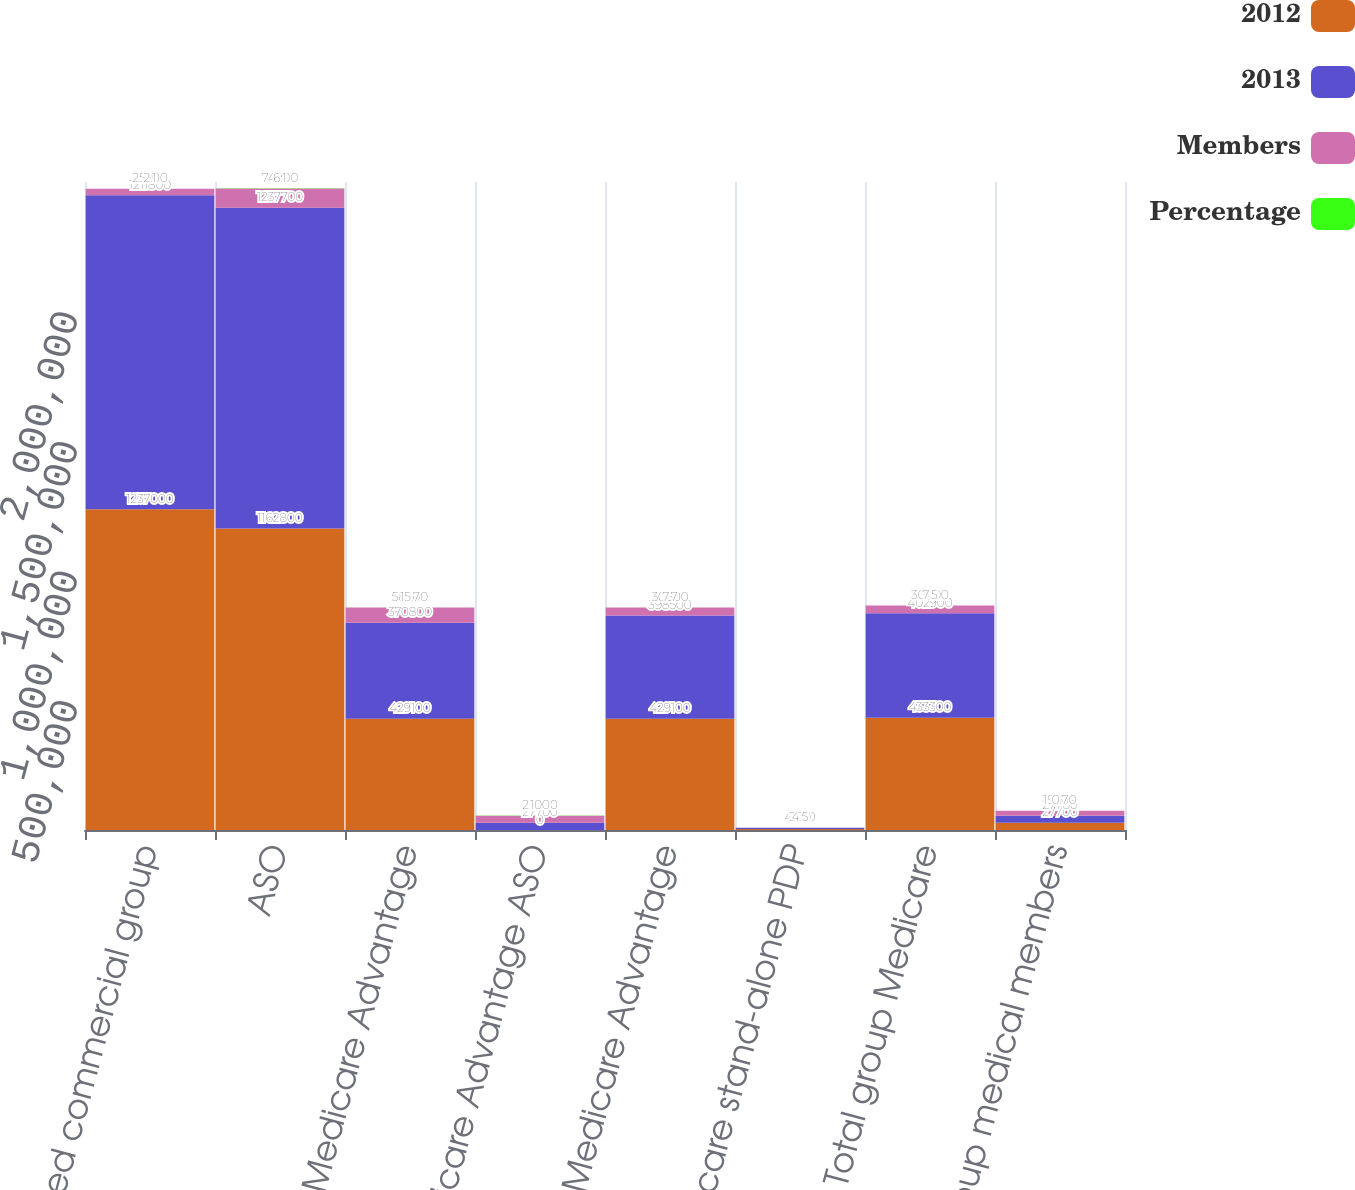Convert chart to OTSL. <chart><loc_0><loc_0><loc_500><loc_500><stacked_bar_chart><ecel><fcel>Fully-insured commercial group<fcel>ASO<fcel>Group Medicare Advantage<fcel>Medicare Advantage ASO<fcel>Total group Medicare Advantage<fcel>Group Medicare stand-alone PDP<fcel>Total group Medicare<fcel>Total group medical members<nl><fcel>2012<fcel>1.237e+06<fcel>1.1628e+06<fcel>429100<fcel>0<fcel>429100<fcel>4200<fcel>433300<fcel>27700<nl><fcel>2013<fcel>1.2118e+06<fcel>1.2377e+06<fcel>370800<fcel>27700<fcel>398500<fcel>4400<fcel>402900<fcel>27700<nl><fcel>Members<fcel>25200<fcel>74900<fcel>58300<fcel>27700<fcel>30600<fcel>200<fcel>30400<fcel>19300<nl><fcel>Percentage<fcel>2.1<fcel>6.1<fcel>15.7<fcel>100<fcel>7.7<fcel>4.5<fcel>7.5<fcel>0.7<nl></chart> 